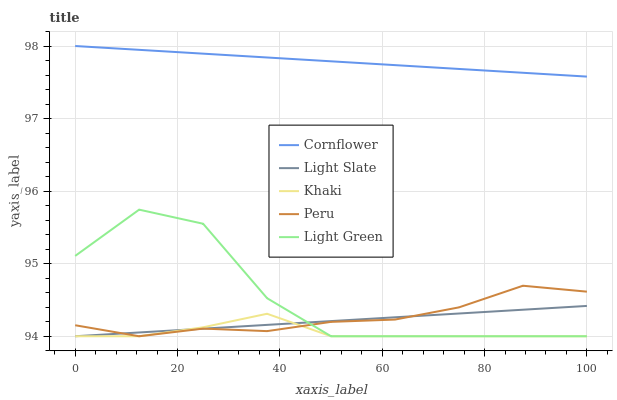Does Khaki have the minimum area under the curve?
Answer yes or no. Yes. Does Cornflower have the maximum area under the curve?
Answer yes or no. Yes. Does Cornflower have the minimum area under the curve?
Answer yes or no. No. Does Khaki have the maximum area under the curve?
Answer yes or no. No. Is Light Slate the smoothest?
Answer yes or no. Yes. Is Light Green the roughest?
Answer yes or no. Yes. Is Cornflower the smoothest?
Answer yes or no. No. Is Cornflower the roughest?
Answer yes or no. No. Does Light Slate have the lowest value?
Answer yes or no. Yes. Does Cornflower have the lowest value?
Answer yes or no. No. Does Cornflower have the highest value?
Answer yes or no. Yes. Does Khaki have the highest value?
Answer yes or no. No. Is Light Slate less than Cornflower?
Answer yes or no. Yes. Is Cornflower greater than Peru?
Answer yes or no. Yes. Does Peru intersect Light Slate?
Answer yes or no. Yes. Is Peru less than Light Slate?
Answer yes or no. No. Is Peru greater than Light Slate?
Answer yes or no. No. Does Light Slate intersect Cornflower?
Answer yes or no. No. 